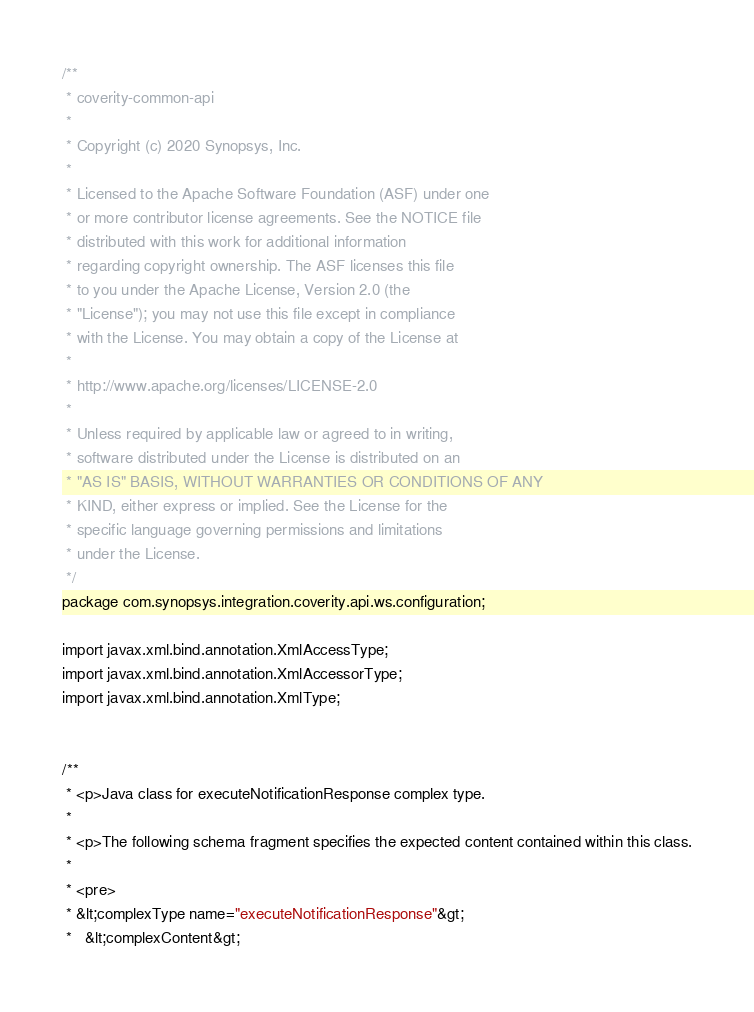Convert code to text. <code><loc_0><loc_0><loc_500><loc_500><_Java_>/**
 * coverity-common-api
 *
 * Copyright (c) 2020 Synopsys, Inc.
 *
 * Licensed to the Apache Software Foundation (ASF) under one
 * or more contributor license agreements. See the NOTICE file
 * distributed with this work for additional information
 * regarding copyright ownership. The ASF licenses this file
 * to you under the Apache License, Version 2.0 (the
 * "License"); you may not use this file except in compliance
 * with the License. You may obtain a copy of the License at
 *
 * http://www.apache.org/licenses/LICENSE-2.0
 *
 * Unless required by applicable law or agreed to in writing,
 * software distributed under the License is distributed on an
 * "AS IS" BASIS, WITHOUT WARRANTIES OR CONDITIONS OF ANY
 * KIND, either express or implied. See the License for the
 * specific language governing permissions and limitations
 * under the License.
 */
package com.synopsys.integration.coverity.api.ws.configuration;

import javax.xml.bind.annotation.XmlAccessType;
import javax.xml.bind.annotation.XmlAccessorType;
import javax.xml.bind.annotation.XmlType;


/**
 * <p>Java class for executeNotificationResponse complex type.
 * 
 * <p>The following schema fragment specifies the expected content contained within this class.
 * 
 * <pre>
 * &lt;complexType name="executeNotificationResponse"&gt;
 *   &lt;complexContent&gt;</code> 